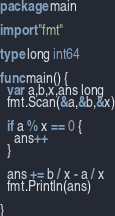Convert code to text. <code><loc_0><loc_0><loc_500><loc_500><_Go_>package main

import "fmt"

type long int64

func main() {
  var a,b,x,ans long
  fmt.Scan(&a,&b,&x)
  
  if a % x == 0 {
    ans++
  }
  
  ans += b / x - a / x
  fmt.Println(ans)
  
}</code> 